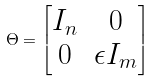<formula> <loc_0><loc_0><loc_500><loc_500>\Theta = \begin{bmatrix} I _ { n } & 0 \\ 0 & \epsilon I _ { m } \end{bmatrix}</formula> 